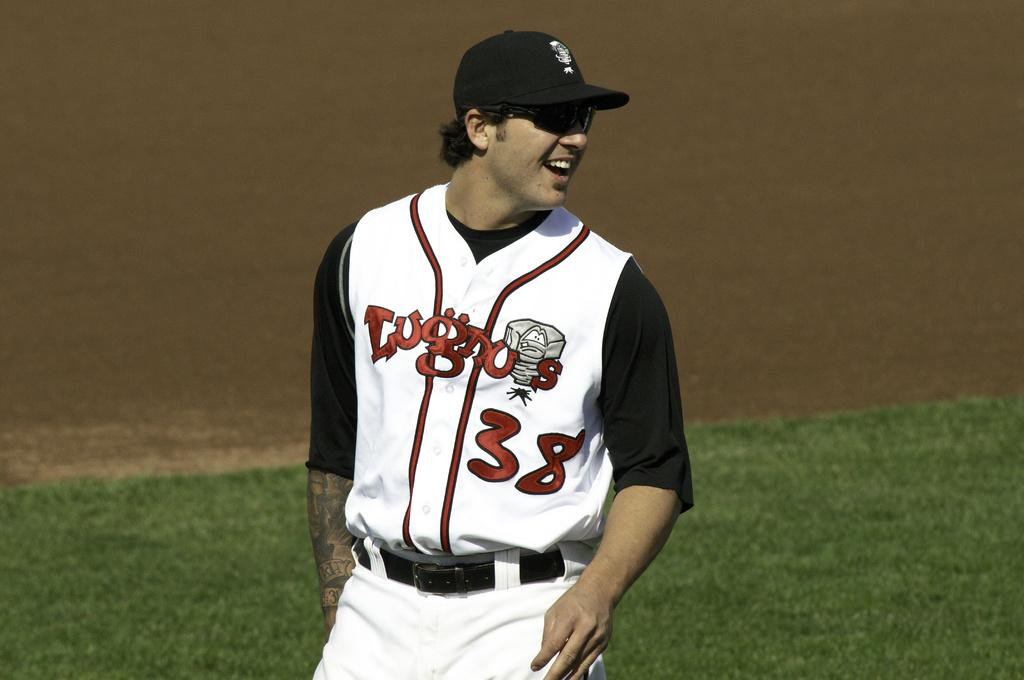Who is the main subject in the image? There is a man in the image. Where is the man positioned in the image? The man is standing in the center of the image. What is the man's facial expression in the image? The man is smiling in the image. What type of terrain can be seen in the background of the image? There is grass on the ground in the background of the image. What type of rock is the man holding in the image? There is no rock present in the image; the man is not holding anything. 